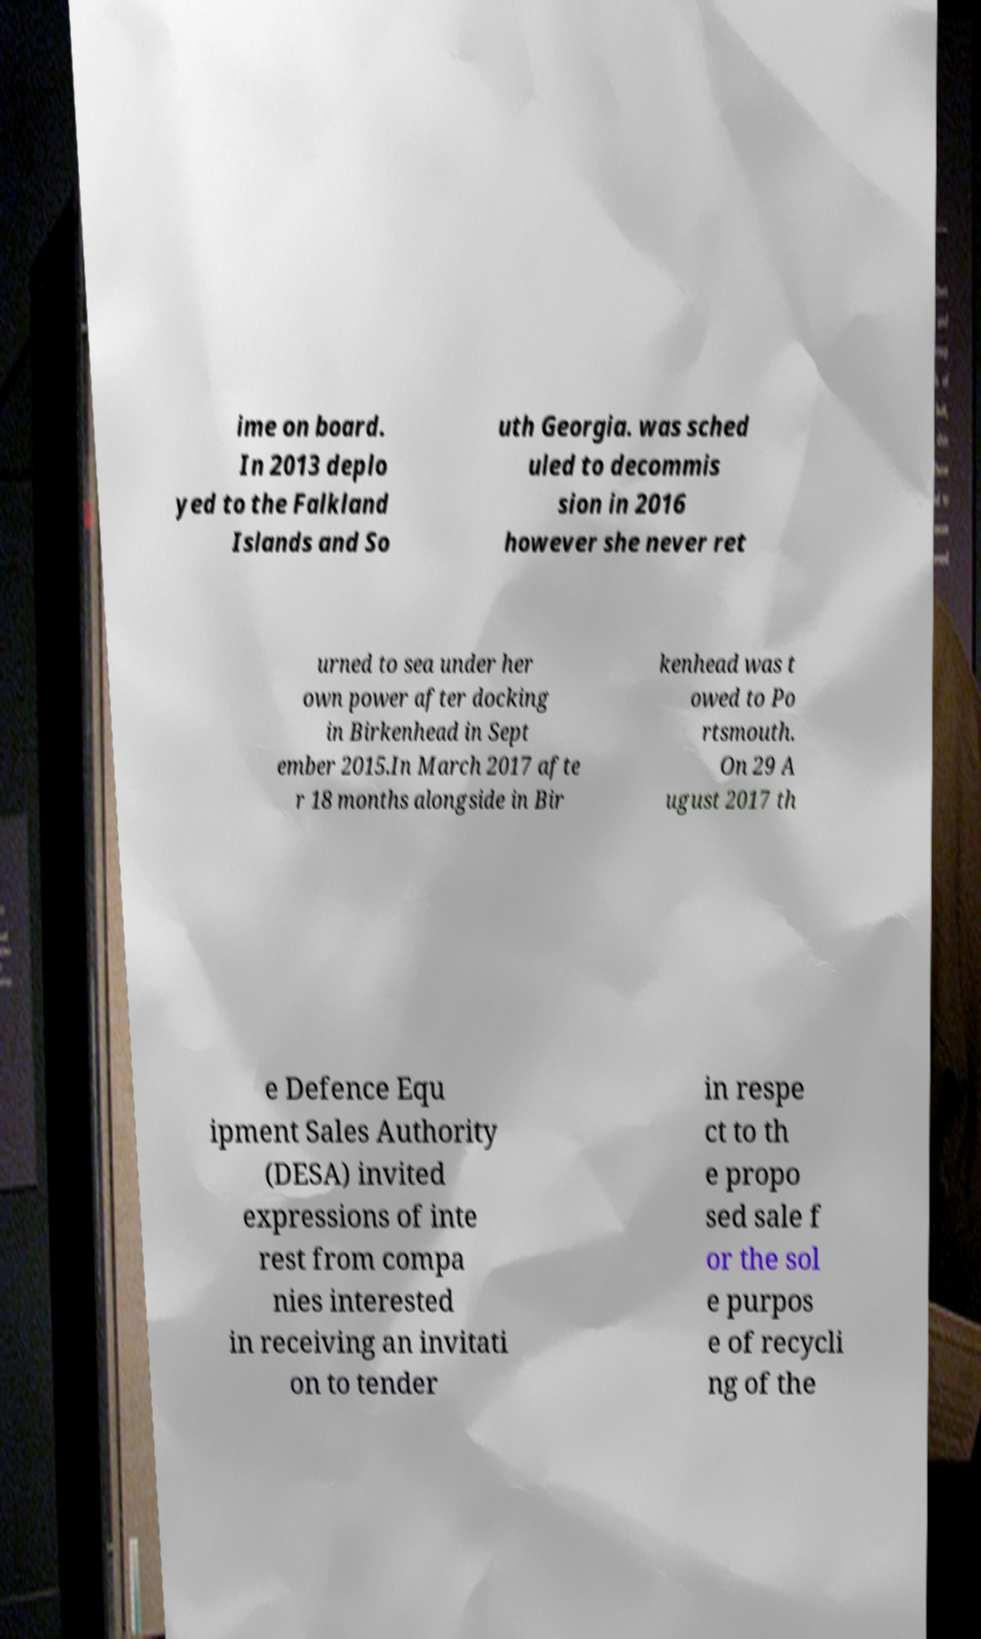Please identify and transcribe the text found in this image. ime on board. In 2013 deplo yed to the Falkland Islands and So uth Georgia. was sched uled to decommis sion in 2016 however she never ret urned to sea under her own power after docking in Birkenhead in Sept ember 2015.In March 2017 afte r 18 months alongside in Bir kenhead was t owed to Po rtsmouth. On 29 A ugust 2017 th e Defence Equ ipment Sales Authority (DESA) invited expressions of inte rest from compa nies interested in receiving an invitati on to tender in respe ct to th e propo sed sale f or the sol e purpos e of recycli ng of the 